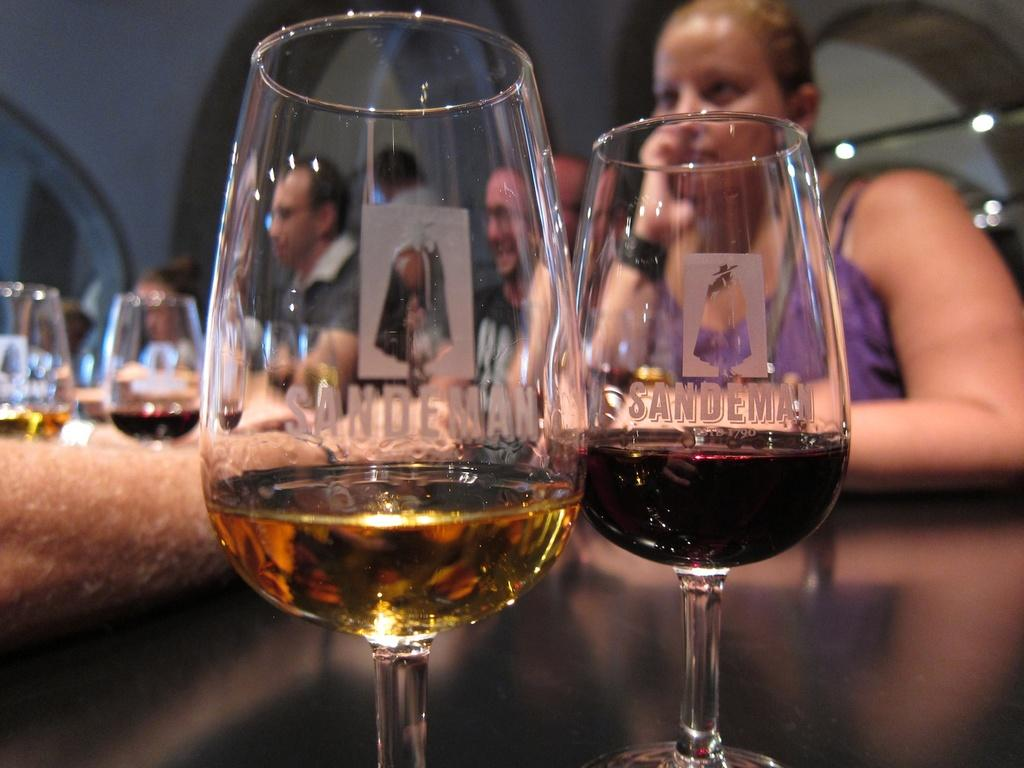What objects are located in the front of the image? There are glasses in the front of the image. What can be seen in the background of the image? There are persons visible in the background of the image. Where are the glasses located on the left side of the image? There are glasses on the left side of the image. Whose hand is visible in the image? The hand of a person is visible in the image. What type of bone is being held by the person in the image? There is no bone visible in the image; only glasses, persons in the background, and a hand are present. 